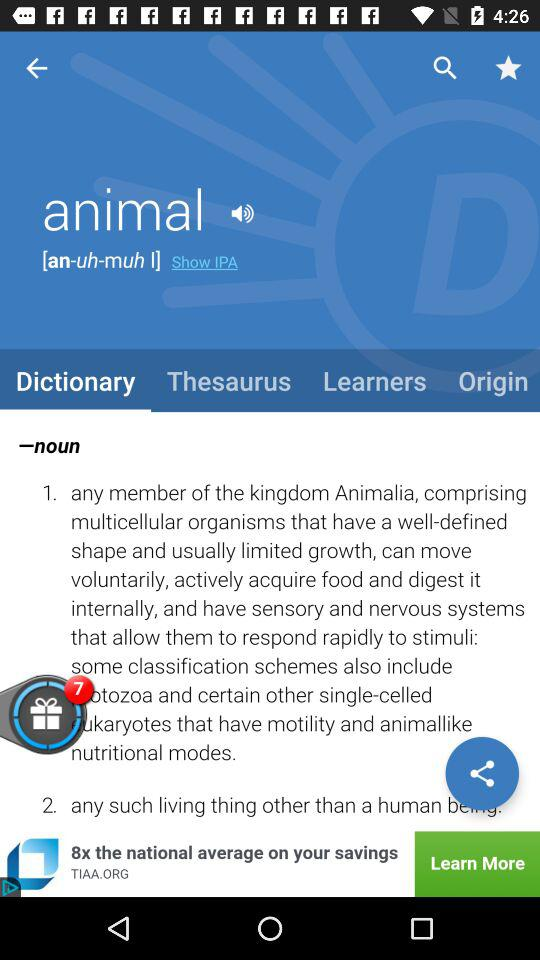Which tab is selected? The selected tab is "Dictionary". 